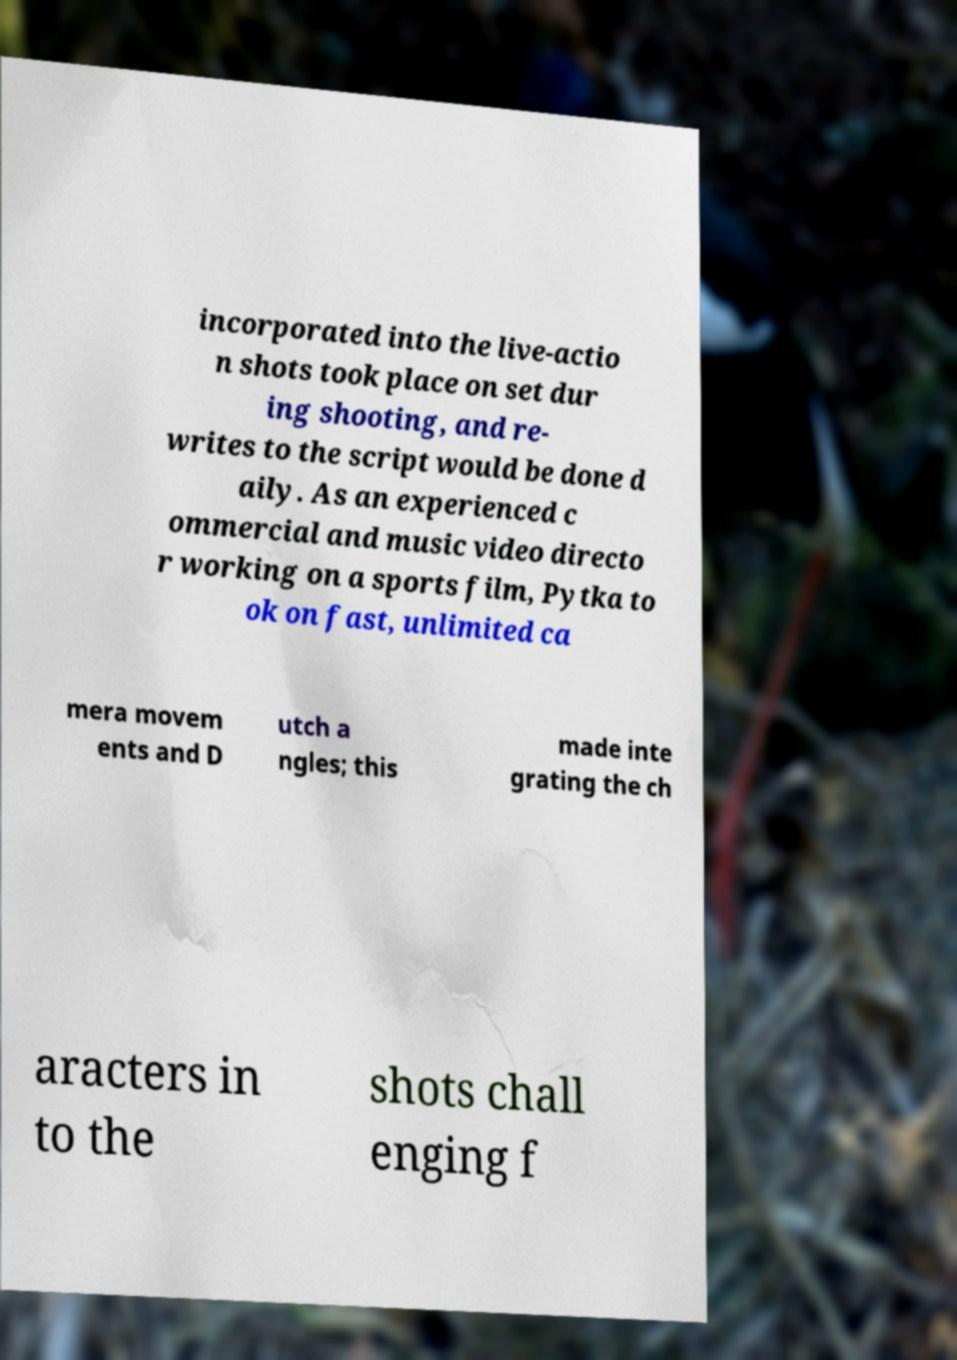Please read and relay the text visible in this image. What does it say? incorporated into the live-actio n shots took place on set dur ing shooting, and re- writes to the script would be done d aily. As an experienced c ommercial and music video directo r working on a sports film, Pytka to ok on fast, unlimited ca mera movem ents and D utch a ngles; this made inte grating the ch aracters in to the shots chall enging f 